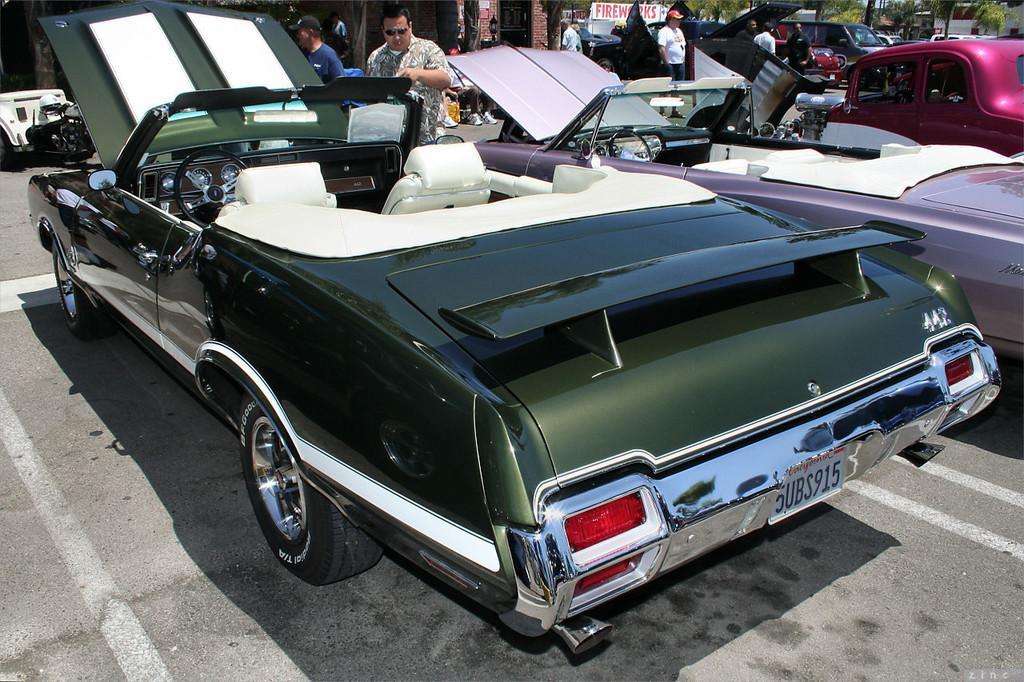How would you summarize this image in a sentence or two? In this picture, we see cars parked on the road. Behind them, there are people standing on the road. There are many trees and a building in the background. We see a white board with some text written on it. This picture is clicked outside the city. 